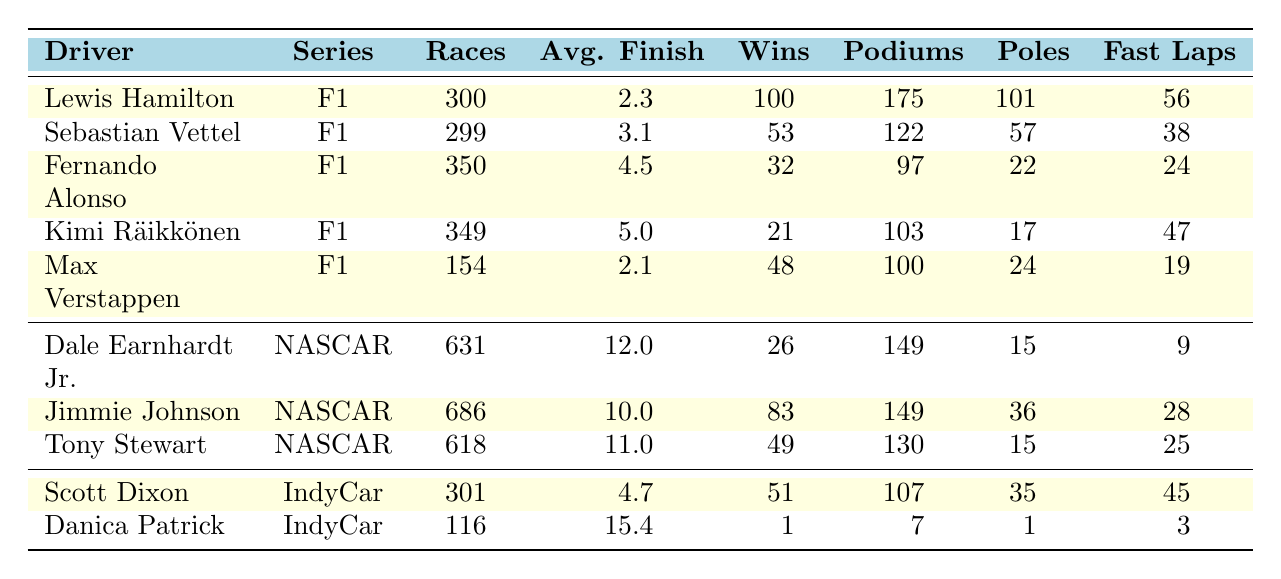What is the average finish position of Lewis Hamilton? The table states that Lewis Hamilton's average finish is 2.3.
Answer: 2.3 How many wins does Max Verstappen have? The table shows that Max Verstappen has 48 wins.
Answer: 48 Which driver has the most podiums in the IndyCar Series? Scott Dixon has 107 podiums, which is more than Danica Patrick's 7 podiums. Thus, he has the most podiums in IndyCar.
Answer: Scott Dixon What is the total number of races participated by Jimmie Johnson and Dale Earnhardt Jr. combined? Jimmie Johnson participated in 686 races and Dale Earnhardt Jr. participated in 631 races, so the total is 686 + 631 = 1317.
Answer: 1317 Does Kimi Räikkönen have more wins or podiums? Kimi Räikkönen has 21 wins and 103 podiums; since 103 is greater than 21, he has more podiums.
Answer: Yes, more podiums What is the average number of wins for all drivers listed in Formula 1? Adding the wins of all drivers in F1: (100 + 53 + 32 + 21 + 48) = 254. There are 5 drivers, so the average wins is 254/5 = 50.8.
Answer: 50.8 Which NASCAR driver has the highest average finish? Jimmie Johnson has an average finish of 10.0, which is the lowest number among the NASCAR drivers; both Dale Earnhardt Jr. has 12.0 and Tony Stewart has 11.0 average finishes, meaning Johnson has the highest.
Answer: Jimmie Johnson How many pole positions does Sebastian Vettel have compared to Max Verstappen? Sebastian Vettel has 57 pole positions while Max Verstappen has 24. Since 57 is greater than 24, Vettel has more pole positions.
Answer: Sebastian Vettel If Lewis Hamilton and Jimmie Johnson were to race against each other, which driver has a better average finish? Lewis Hamilton has an average finish of 2.3 while Jimmie Johnson has 10.0. Since 2.3 is better (lower) than 10.0, Hamilton has a better average finish.
Answer: Lewis Hamilton What is the ratio of the fastest laps between Tony Stewart and Scott Dixon? Tony Stewart has 25 fastest laps and Scott Dixon has 45. The ratio is 25:45, which simplifies to 5:9.
Answer: 5:9 